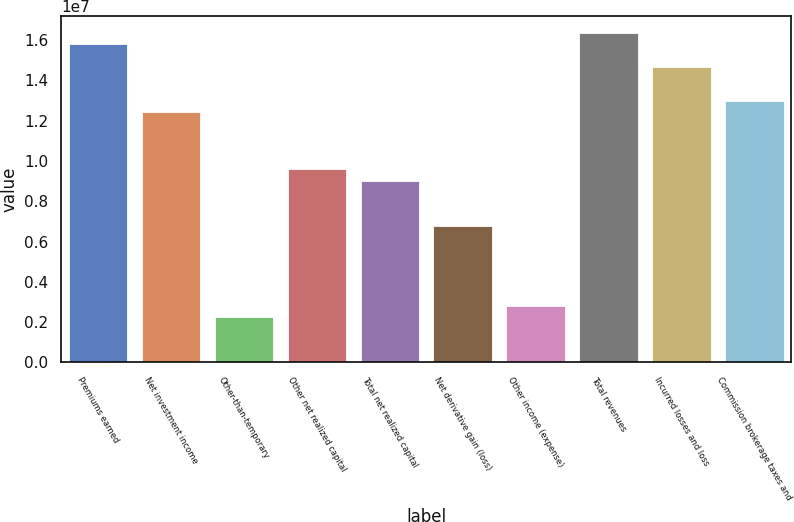Convert chart to OTSL. <chart><loc_0><loc_0><loc_500><loc_500><bar_chart><fcel>Premiums earned<fcel>Net investment income<fcel>Other-than-temporary<fcel>Other net realized capital<fcel>Total net realized capital<fcel>Net derivative gain (loss)<fcel>Other income (expense)<fcel>Total revenues<fcel>Incurred losses and loss<fcel>Commission brokerage taxes and<nl><fcel>1.57943e+07<fcel>1.24098e+07<fcel>2.25634e+06<fcel>9.58942e+06<fcel>9.02534e+06<fcel>6.769e+06<fcel>2.82042e+06<fcel>1.63584e+07<fcel>1.46662e+07<fcel>1.29739e+07<nl></chart> 